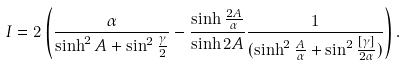Convert formula to latex. <formula><loc_0><loc_0><loc_500><loc_500>I = 2 \left ( { \frac { \alpha } { \sinh ^ { 2 } A + \sin ^ { 2 } { \frac { \gamma } { 2 } } } } - { \frac { \sinh { \frac { 2 A } { \alpha } } } { \sinh { 2 A } } } { \frac { 1 } { ( \sinh ^ { 2 } { \frac { A } { \alpha } } + \sin ^ { 2 } { \frac { [ \gamma ] } { 2 \alpha } } ) } } \right ) .</formula> 